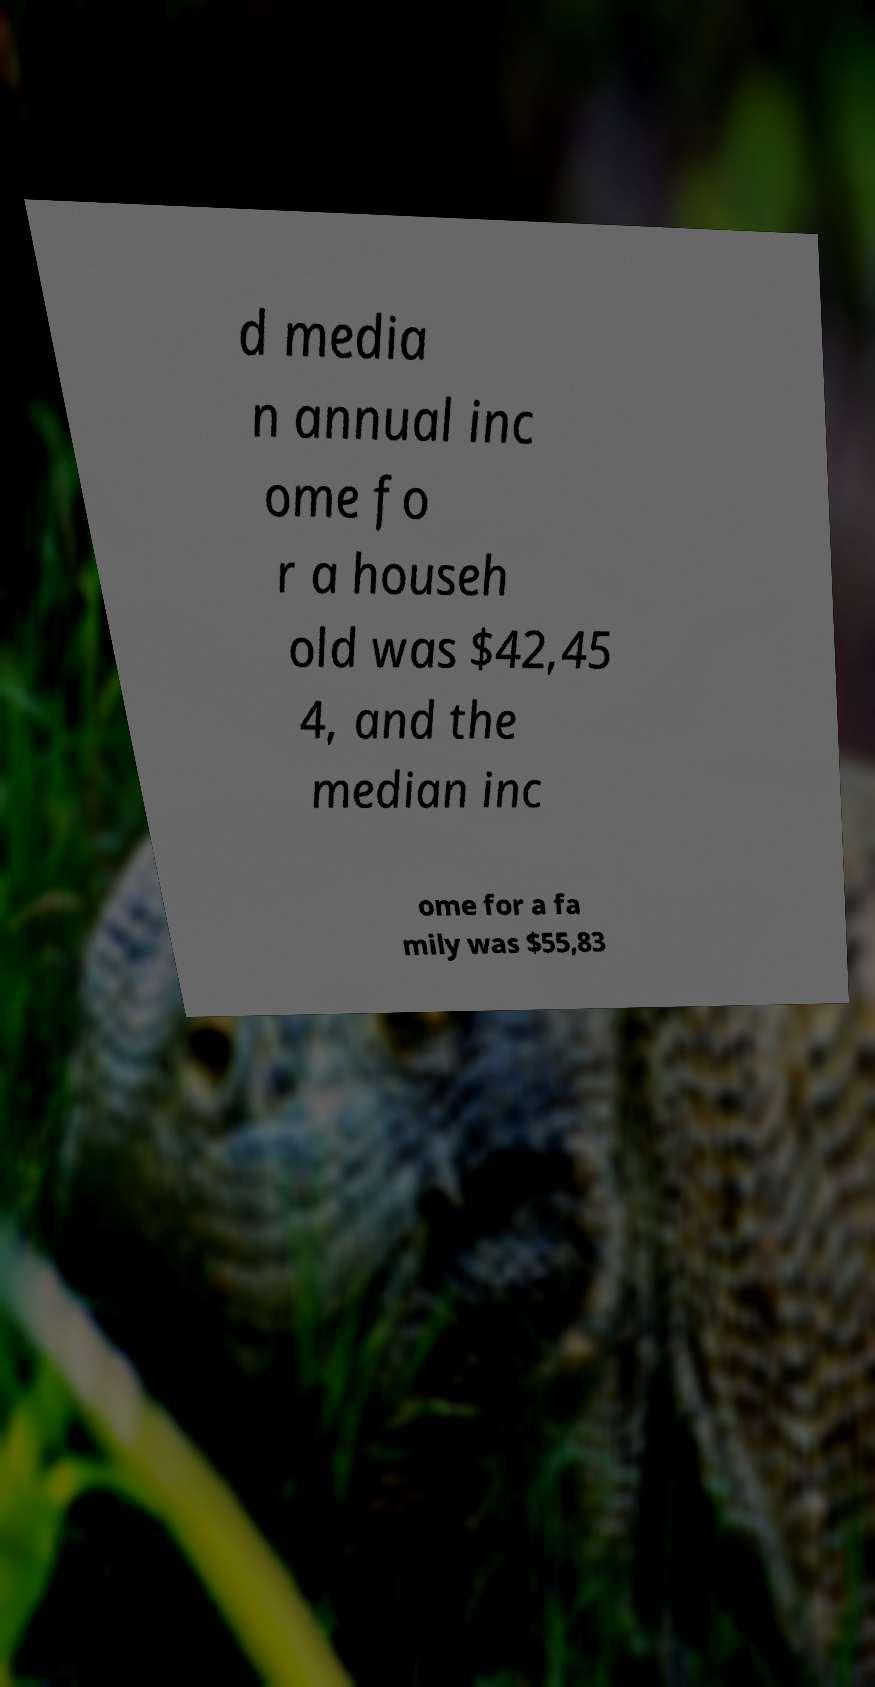Please identify and transcribe the text found in this image. d media n annual inc ome fo r a househ old was $42,45 4, and the median inc ome for a fa mily was $55,83 